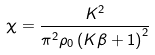Convert formula to latex. <formula><loc_0><loc_0><loc_500><loc_500>\chi = \frac { K ^ { 2 } } { \pi ^ { 2 } \rho _ { 0 } \left ( K \beta + 1 \right ) ^ { 2 } }</formula> 